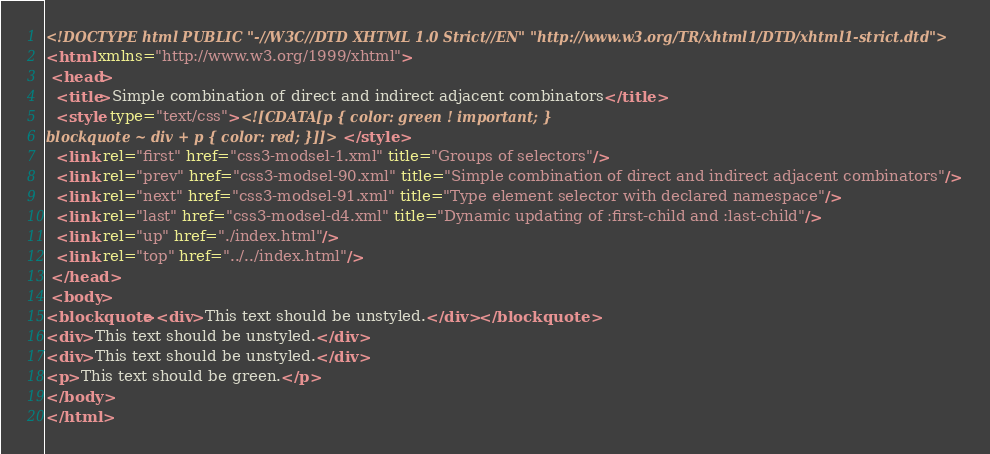Convert code to text. <code><loc_0><loc_0><loc_500><loc_500><_XML_><!DOCTYPE html PUBLIC "-//W3C//DTD XHTML 1.0 Strict//EN" "http://www.w3.org/TR/xhtml1/DTD/xhtml1-strict.dtd">
<html xmlns="http://www.w3.org/1999/xhtml">
 <head>
  <title>Simple combination of direct and indirect adjacent combinators</title>
  <style type="text/css"><![CDATA[p { color: green ! important; }
blockquote ~ div + p { color: red; }]]></style>
  <link rel="first" href="css3-modsel-1.xml" title="Groups of selectors"/>
  <link rel="prev" href="css3-modsel-90.xml" title="Simple combination of direct and indirect adjacent combinators"/>
  <link rel="next" href="css3-modsel-91.xml" title="Type element selector with declared namespace"/>
  <link rel="last" href="css3-modsel-d4.xml" title="Dynamic updating of :first-child and :last-child"/>
  <link rel="up" href="./index.html"/>
  <link rel="top" href="../../index.html"/>
 </head>
 <body>
<blockquote><div>This text should be unstyled.</div></blockquote>
<div>This text should be unstyled.</div>
<div>This text should be unstyled.</div>
<p>This text should be green.</p>
</body>
</html></code> 